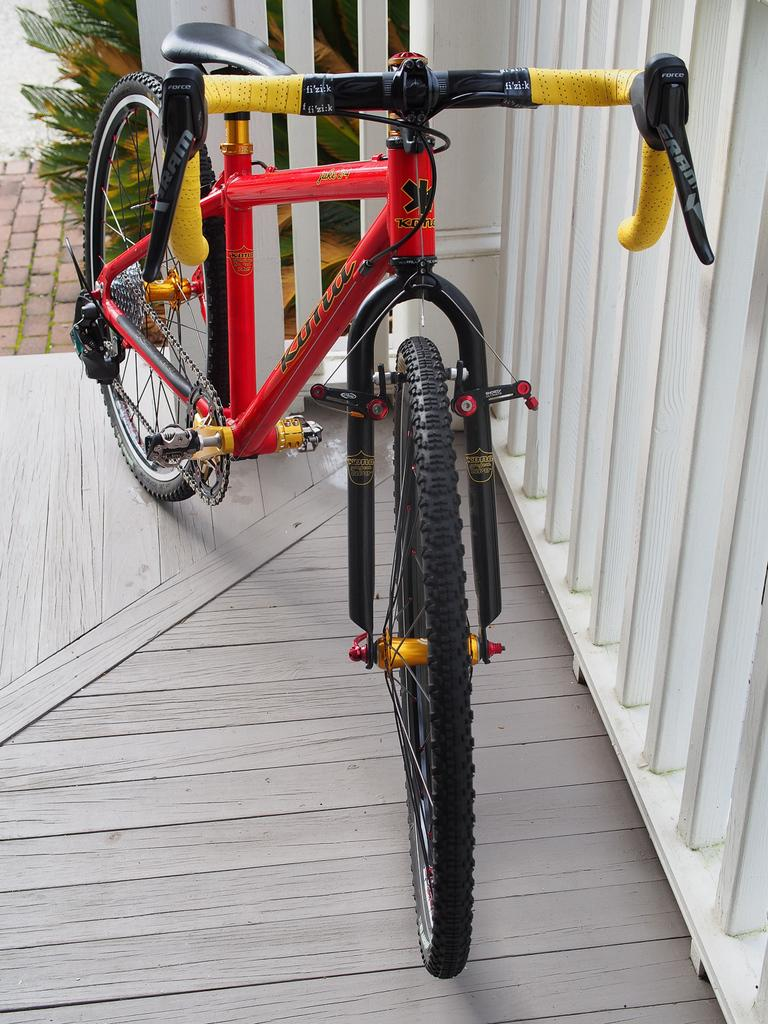What is the main subject in the center of the image? There is a bicycle in the center of the image. What can be seen on the right side of the image? There is a white fence on the right side of the image. What type of vegetation or plants can be seen in the background of the image? There are plants in the background of the image. What type of popcorn can be smelled in the image? There is no popcorn present in the image, and therefore no smell can be detected. 